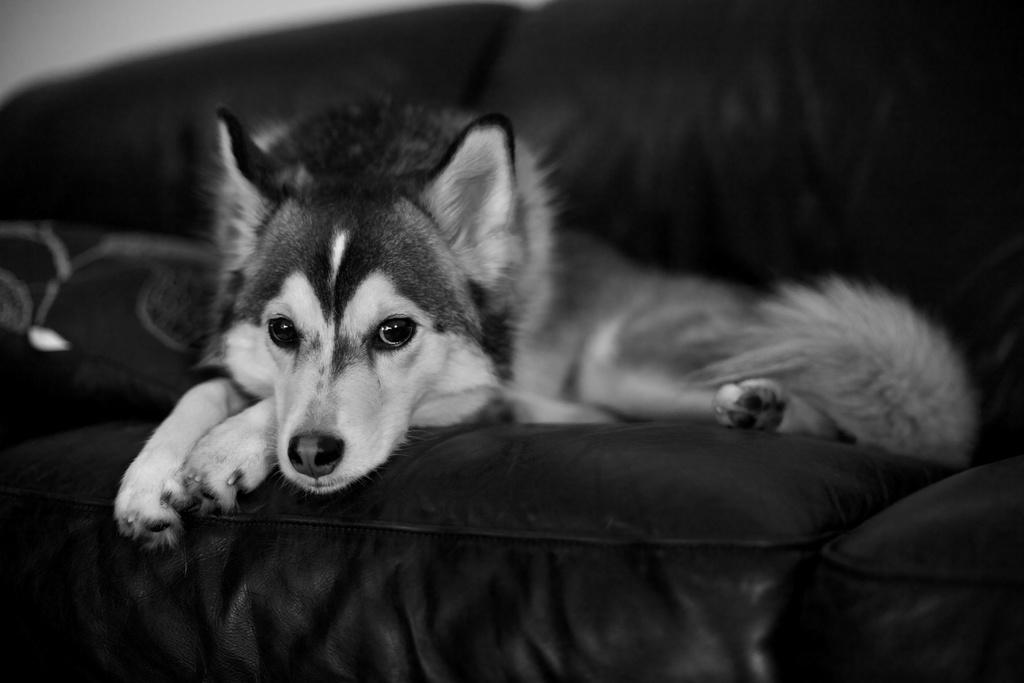What type of animal is in the picture? There is a dog in the picture. Where is the dog located in the image? The dog is on a couch. What is the color scheme of the picture? The picture is in black and white. What type of bird is sitting on the dog's toys in the image? There are no birds or toys present in the image; it only features a dog on a couch in black and white. 